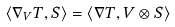Convert formula to latex. <formula><loc_0><loc_0><loc_500><loc_500>\langle \nabla _ { V } T , S \rangle = \langle \nabla T , V \otimes S \rangle</formula> 